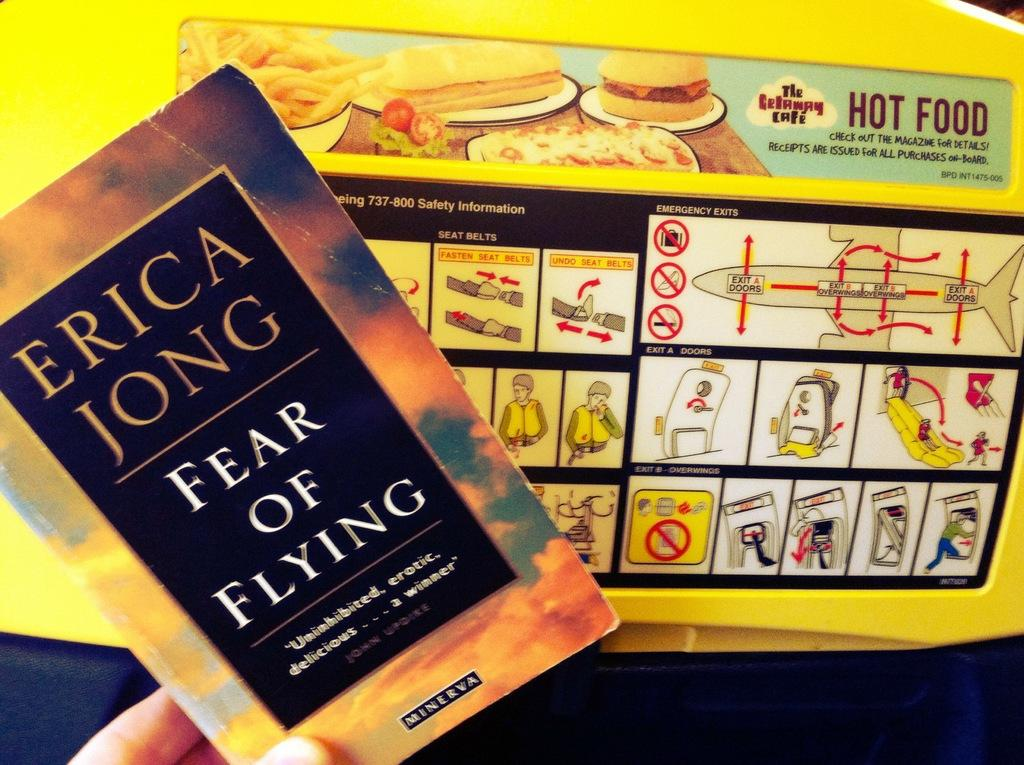<image>
Create a compact narrative representing the image presented. Person holding a book titled Fear of Flying by Erica Jong. 